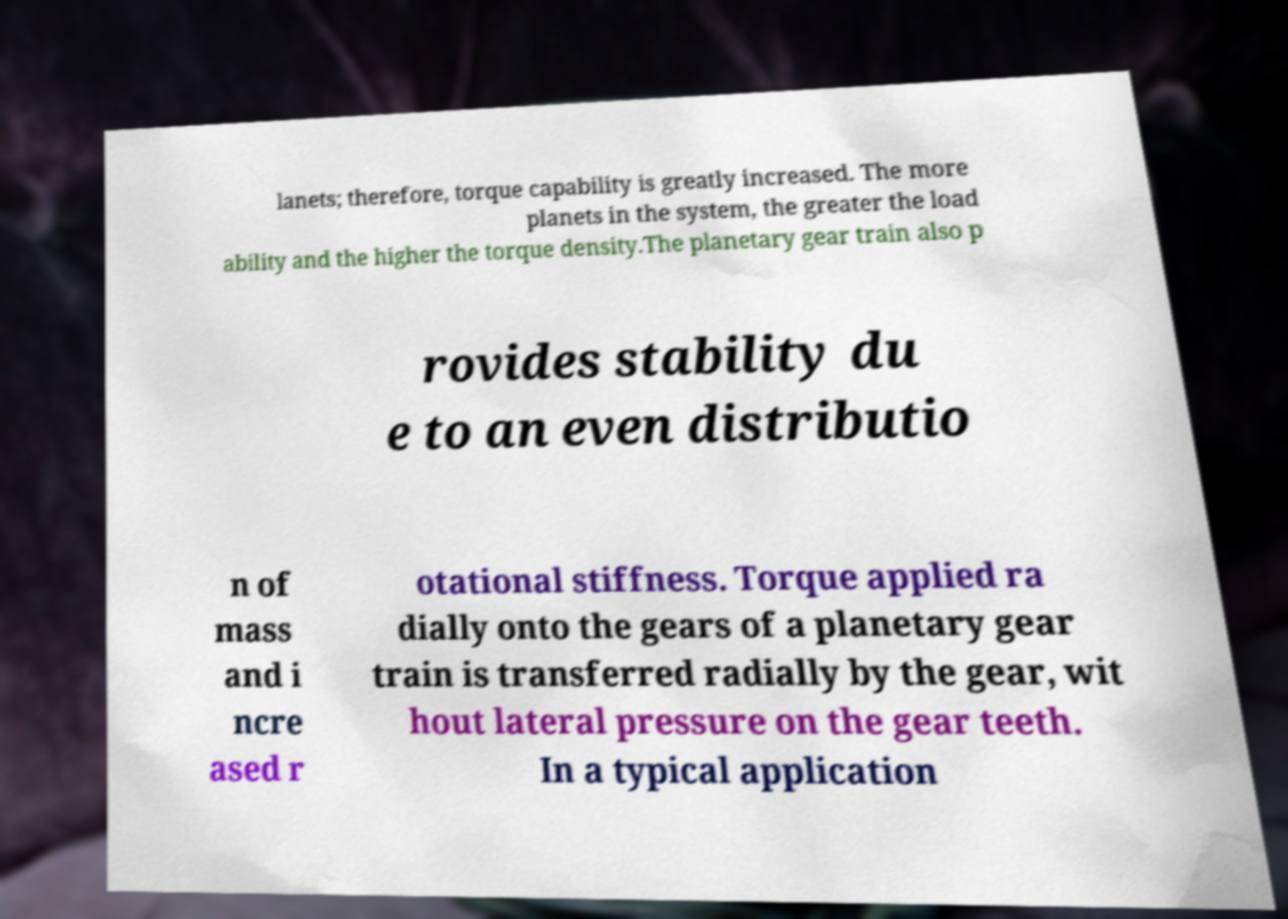Can you read and provide the text displayed in the image?This photo seems to have some interesting text. Can you extract and type it out for me? lanets; therefore, torque capability is greatly increased. The more planets in the system, the greater the load ability and the higher the torque density.The planetary gear train also p rovides stability du e to an even distributio n of mass and i ncre ased r otational stiffness. Torque applied ra dially onto the gears of a planetary gear train is transferred radially by the gear, wit hout lateral pressure on the gear teeth. In a typical application 